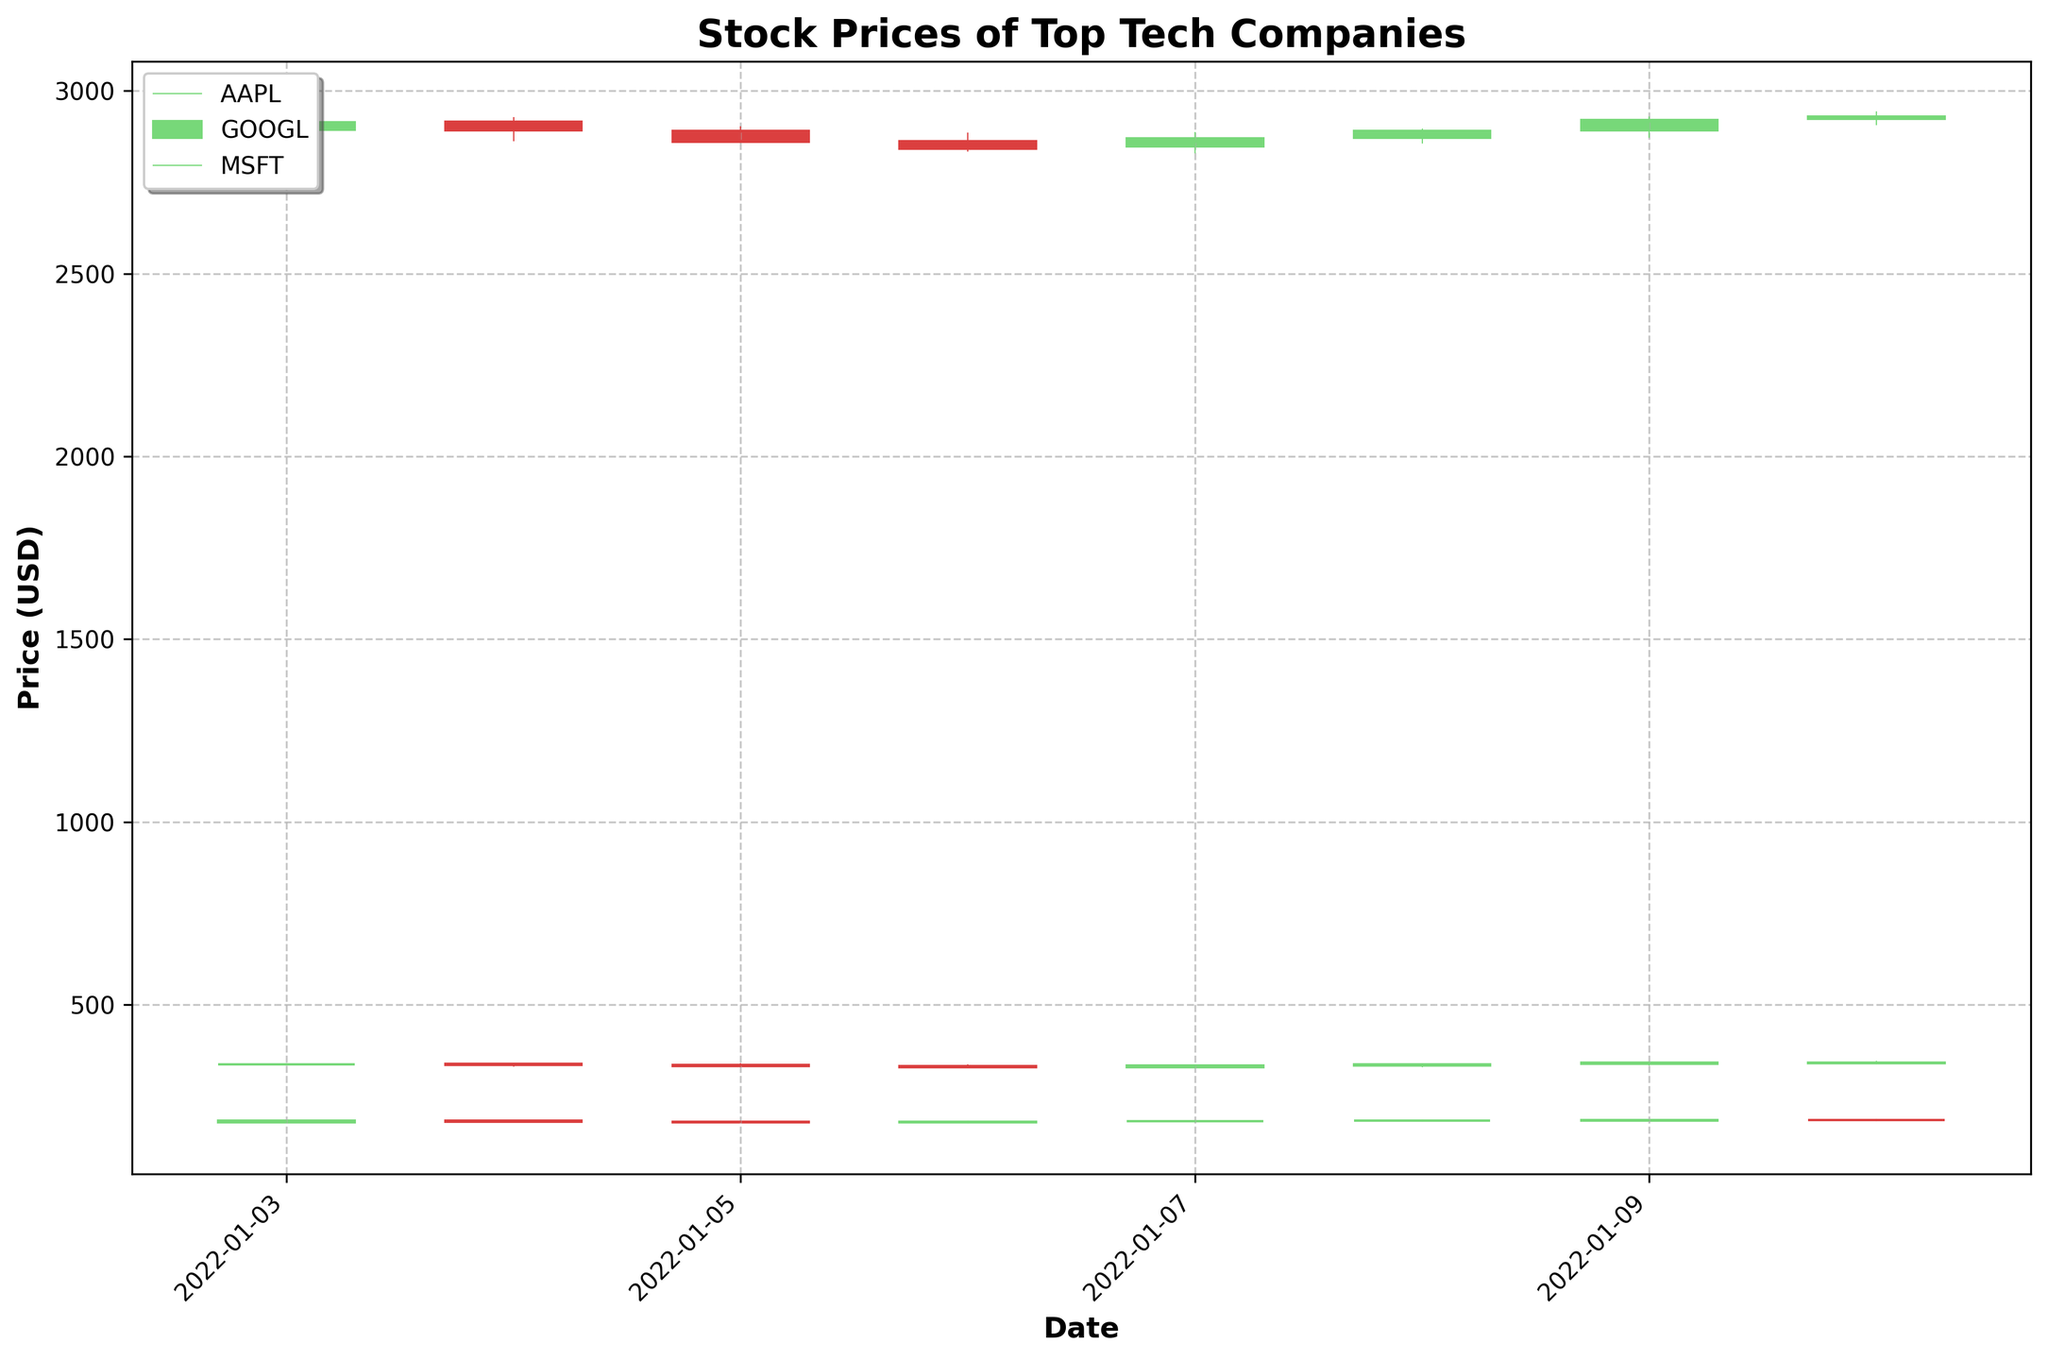How many companies' stock prices are represented in the plot? The legend at the top left of the plot lists the three companies whose stock prices are represented: AAPL, GOOGL, and MSFT.
Answer: Three What is the title of the plot? The title is positioned at the top center of the plot.
Answer: Stock Prices of Top Tech Companies What do the colors of the candlesticks represent? The colors of the candlesticks indicate whether the closing price was higher or lower than the opening price: green (or light color) indicates a price increase, and red (or dark color) indicates a price decrease.
Answer: Price increase and decrease Which company had the highest closing price on January 5, 2022? Looking at the candlesticks for January 5, 2022, compare the closing prices of AAPL, GOOGL, and MSFT as represented by the top of the green/red bars.
Answer: GOOGL On which date did MSFT have its highest intraday price in the given period? Identify the highest point in the candlestick (wick) for MSFT across the dates represented and match it to the corresponding date.
Answer: January 10, 2022 Comparing January 5, 6, and 7 of 2022, which date had the highest closing price for AAPL? Observe and compare the closing price indicators at the top of the candlestick bodies for AAPL on each specified date.
Answer: January 7, 2022 Did GOOGL close higher on January 9, 2022, than it opened on January 10, 2022? Compare the closing price for GOOGL on January 9, 2022, with the opening price on January 10, 2022, as indicated by the ends of the respective candlestick bodies.
Answer: Yes What trend can be observed for MSFT's closing prices from January 5 to January 10, 2022? Follow the ending points of the candlestick bodies for MSFT from January 5 to January 10, 2022, to determine the overall movement in prices.
Answer: Increasing What was the highest volume traded among all the companies on January 3, 2022? Check the volume values for AAPL, GOOGL, and MSFT on January 3, 2022, and identify the highest one.
Answer: 104487900 (AAPL) Is there a date when all three companies closed higher than they opened? Analyze the color of the candlesticks (green) for each company on each date to see if there is a date when all three candlesticks are green.
Answer: January 7, 2022 